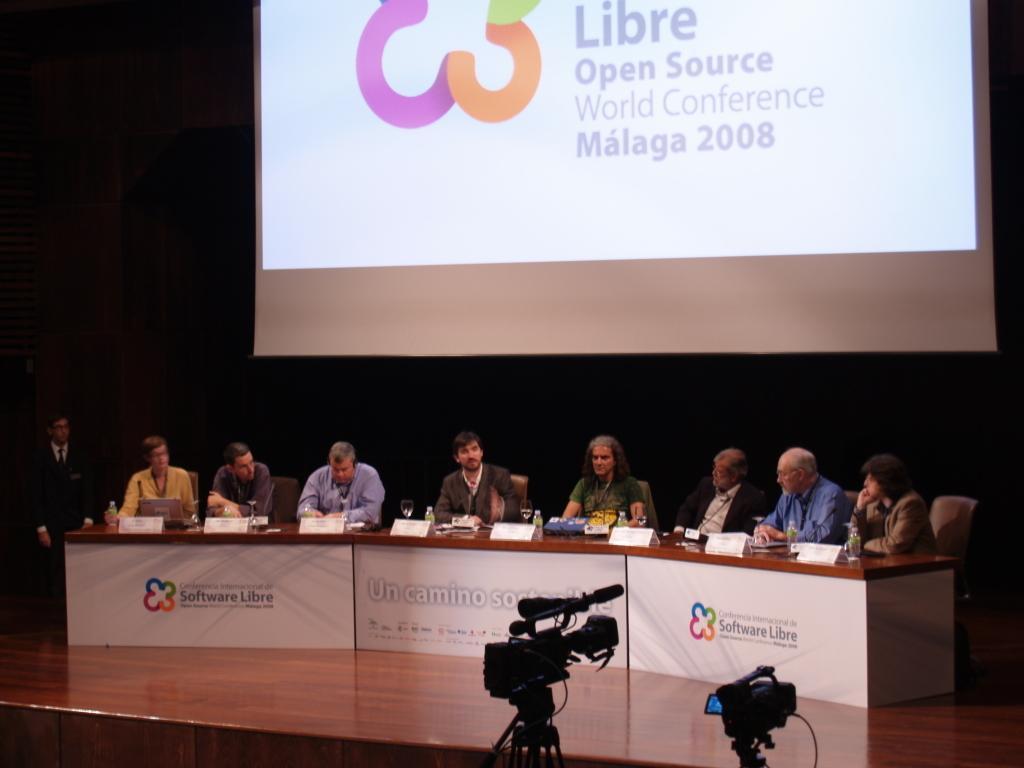Please provide a concise description of this image. In this image in the center there are a group of people who are sitting, and in front of them there is one table. On the table there are some name boards and some objects and in the foreground there are two cameras, in the background there is one screen. On the screen there is some text. 